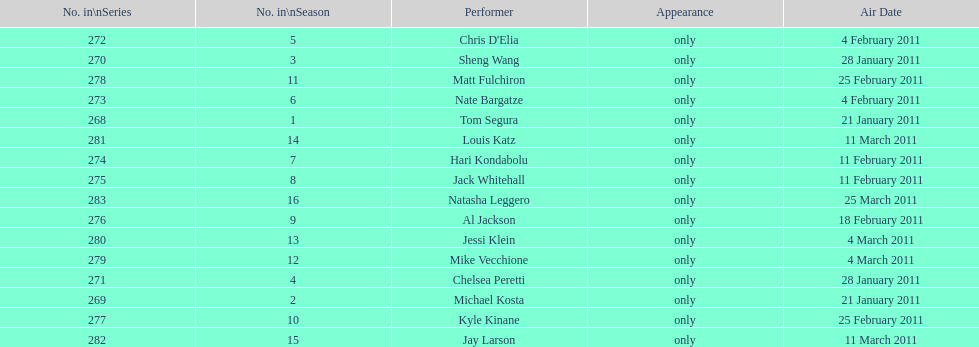Help me parse the entirety of this table. {'header': ['No. in\\nSeries', 'No. in\\nSeason', 'Performer', 'Appearance', 'Air Date'], 'rows': [['272', '5', "Chris D'Elia", 'only', '4 February 2011'], ['270', '3', 'Sheng Wang', 'only', '28 January 2011'], ['278', '11', 'Matt Fulchiron', 'only', '25 February 2011'], ['273', '6', 'Nate Bargatze', 'only', '4 February 2011'], ['268', '1', 'Tom Segura', 'only', '21 January 2011'], ['281', '14', 'Louis Katz', 'only', '11 March 2011'], ['274', '7', 'Hari Kondabolu', 'only', '11 February 2011'], ['275', '8', 'Jack Whitehall', 'only', '11 February 2011'], ['283', '16', 'Natasha Leggero', 'only', '25 March 2011'], ['276', '9', 'Al Jackson', 'only', '18 February 2011'], ['280', '13', 'Jessi Klein', 'only', '4 March 2011'], ['279', '12', 'Mike Vecchione', 'only', '4 March 2011'], ['271', '4', 'Chelsea Peretti', 'only', '28 January 2011'], ['269', '2', 'Michael Kosta', 'only', '21 January 2011'], ['277', '10', 'Kyle Kinane', 'only', '25 February 2011'], ['282', '15', 'Jay Larson', 'only', '11 March 2011']]} How many different performers appeared during this season? 16. 